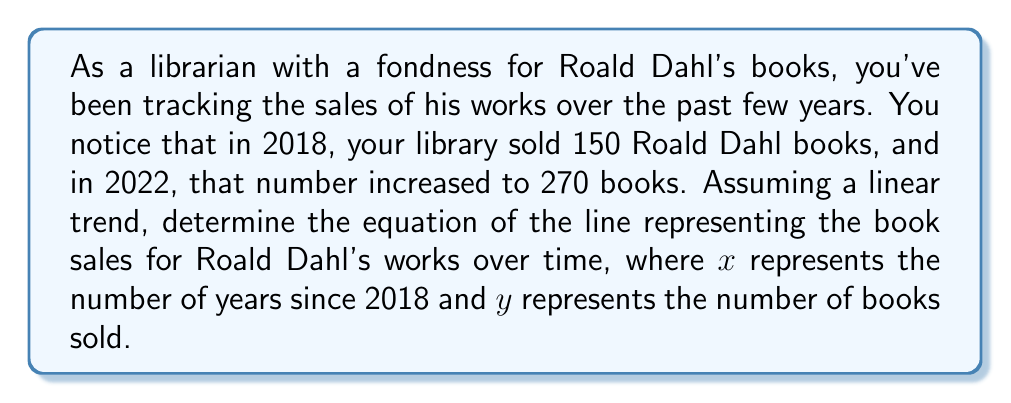Teach me how to tackle this problem. To find the equation of the line, we'll use the point-slope form: $y - y_1 = m(x - x_1)$, where $m$ is the slope of the line.

1. Identify two points:
   $(x_1, y_1) = (0, 150)$ for 2018
   $(x_2, y_2) = (4, 270)$ for 2022

2. Calculate the slope:
   $m = \frac{y_2 - y_1}{x_2 - x_1} = \frac{270 - 150}{4 - 0} = \frac{120}{4} = 30$

3. Use the point-slope form with $(x_1, y_1) = (0, 150)$:
   $y - 150 = 30(x - 0)$

4. Simplify:
   $y - 150 = 30x$

5. Solve for $y$ to get the slope-intercept form:
   $y = 30x + 150$

This equation represents the linear trend of Roald Dahl book sales over time, where $x$ is the number of years since 2018 and $y$ is the number of books sold.
Answer: $y = 30x + 150$ 